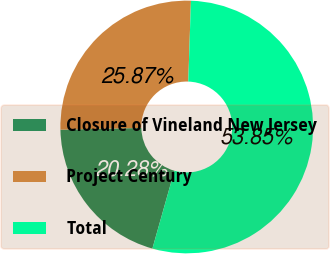<chart> <loc_0><loc_0><loc_500><loc_500><pie_chart><fcel>Closure of Vineland New Jersey<fcel>Project Century<fcel>Total<nl><fcel>20.28%<fcel>25.87%<fcel>53.85%<nl></chart> 